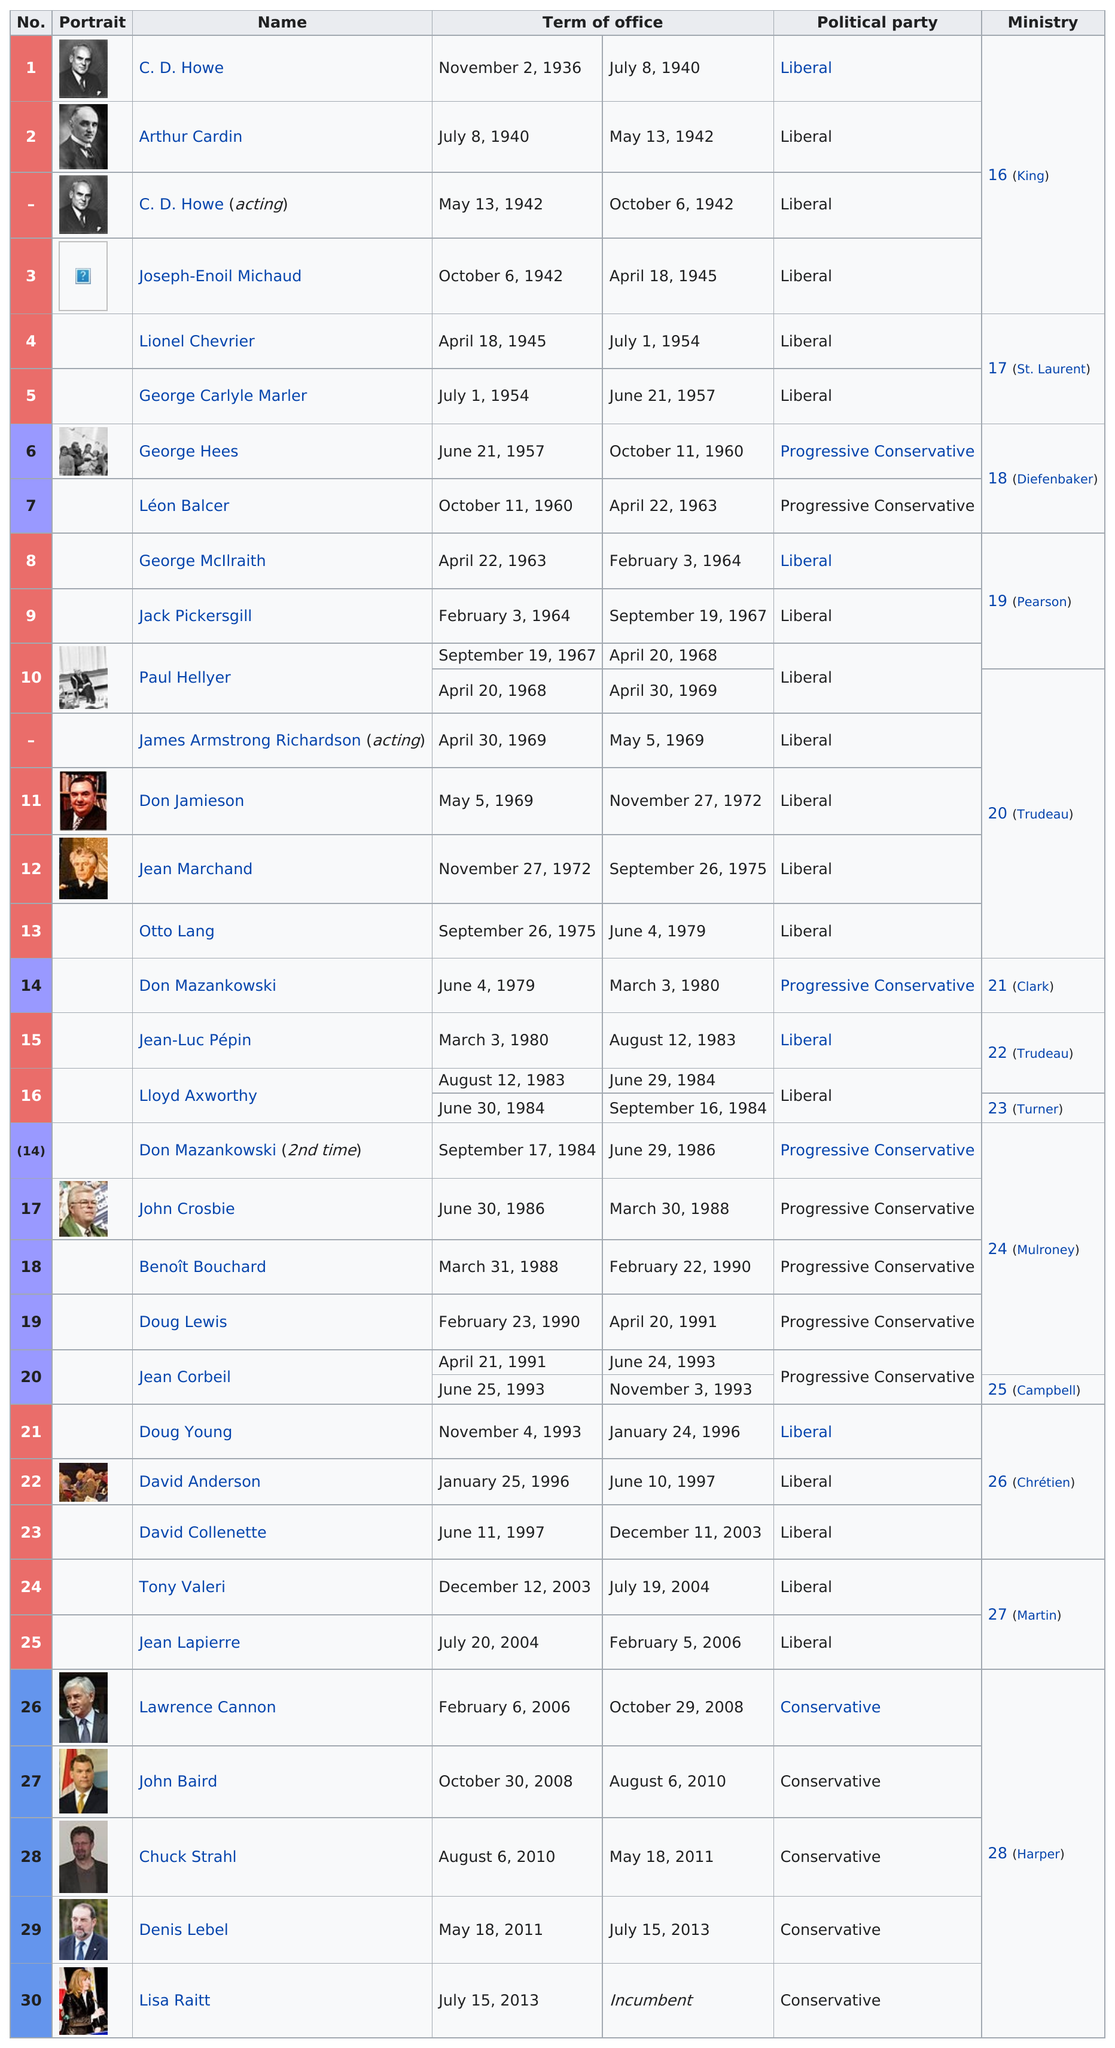Mention a couple of crucial points in this snapshot. There are two members of the Liberal political party from the St. Laurent Ministry. C. D. Howe was the first Minister of Transport. It is known that Joseph-Enoil Michaud belonged to the Liberal political party. The next Minister of Transport after C.D. Howe was Arthur Cardin. George Hees was a member of the Progressive Conservative Party. 